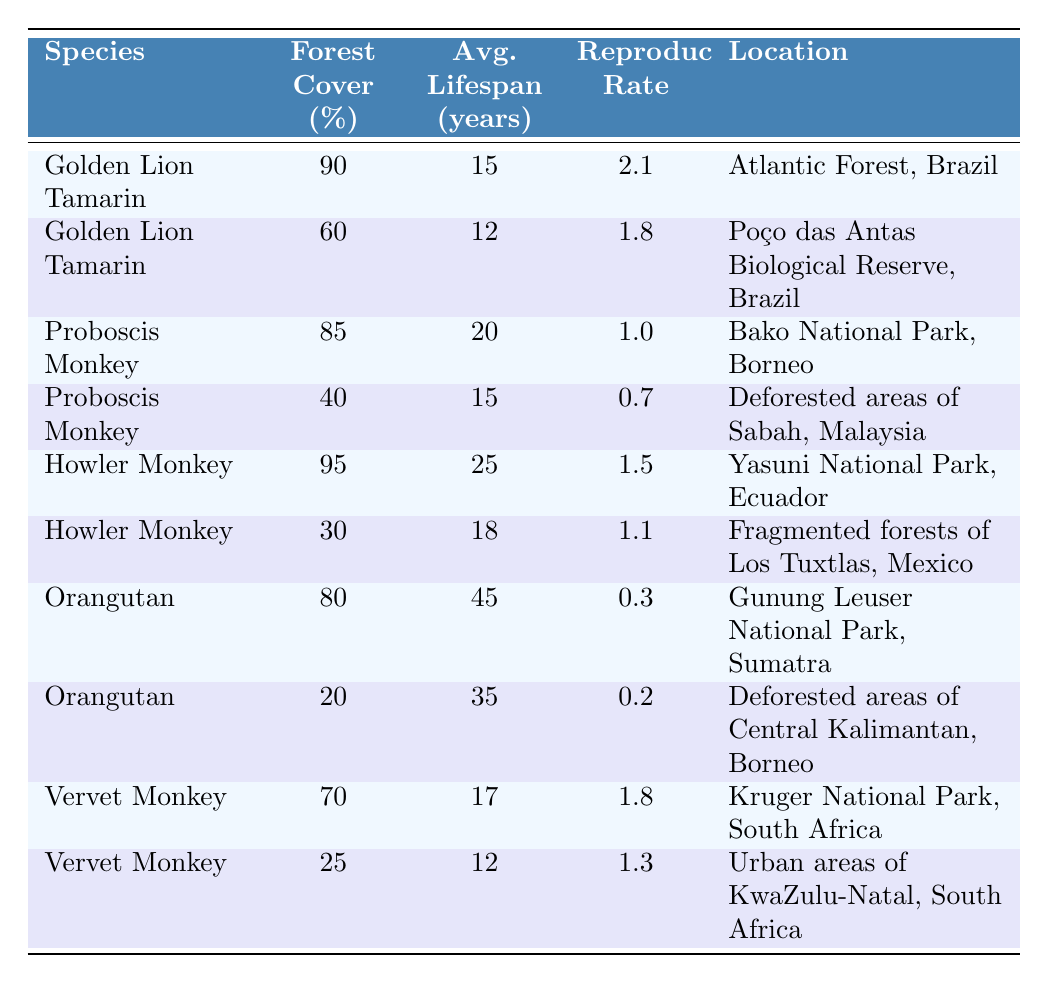What is the average lifespan of the Golden Lion Tamarin in areas with 90% forest cover? The table shows that the Golden Lion Tamarin has an average lifespan of 15 years in areas with 90% forest cover.
Answer: 15 years How many species have an average lifespan greater than 20 years? The average lifespans for the species listed are 15, 12, 20, 15, 25, 18, 45, 35, 17, and 12 years. Only the Howler Monkey (25 years) and Orangutan (45 years) have an average lifespan greater than 20 years, totaling 2 species.
Answer: 2 species What is the reproductive rate of the Vervet Monkey in urban areas? According to the table, the Vervet Monkey has a reproductive rate of 1.3 in urban areas of KwaZulu-Natal, South Africa.
Answer: 1.3 Is the average lifespan of the Howler Monkey in fragmented forests greater than that of the Proboscis Monkey in deforested areas? The Howler Monkey has an average lifespan of 18 years in fragmented forests, while the Proboscis Monkey has an average lifespan of 15 years in deforested areas. Since 18 is greater than 15, the statement is true.
Answer: Yes What is the average reproductive rate of monkeys in areas with less than 50% forest cover? The monkeys listed with less than 50% forest cover are the Proboscis Monkey (0.7 reproductive rate), Howler Monkey (1.1), Orangutan (0.2), and Vervet Monkey (1.3). The average is calculated as (0.7 + 1.1 + 0.2 + 1.3) / 4 = 0.833.
Answer: 0.833 How does the average lifespan of the Orangutan compare at 80% versus 20% forest cover? At 80% forest cover, the Orangutan has an average lifespan of 45 years, while at 20% forest cover, the average lifespan is 35 years. The difference is 45 - 35 = 10 years, indicating a notable decline in lifespan with reduced forest cover.
Answer: 10 years Which monkey species has the highest reproductive rate, and what is its forest cover percentage? The species with the highest reproductive rate is the Golden Lion Tamarin, which has a reproductive rate of 2.1 at 90% forest cover.
Answer: Golden Lion Tamarin, 90% What is the median average lifespan of the monkeys listed in the table? The average lifespans from the table are 15, 12, 20, 15, 25, 18, 45, 35, 17, and 12 years. Arranging them gives: 12, 12, 15, 15, 17, 18, 20, 25, 35, 45. The median of these 10 values is the average of the 5th and 6th values: (17 + 18) / 2 = 17.5 years.
Answer: 17.5 years 